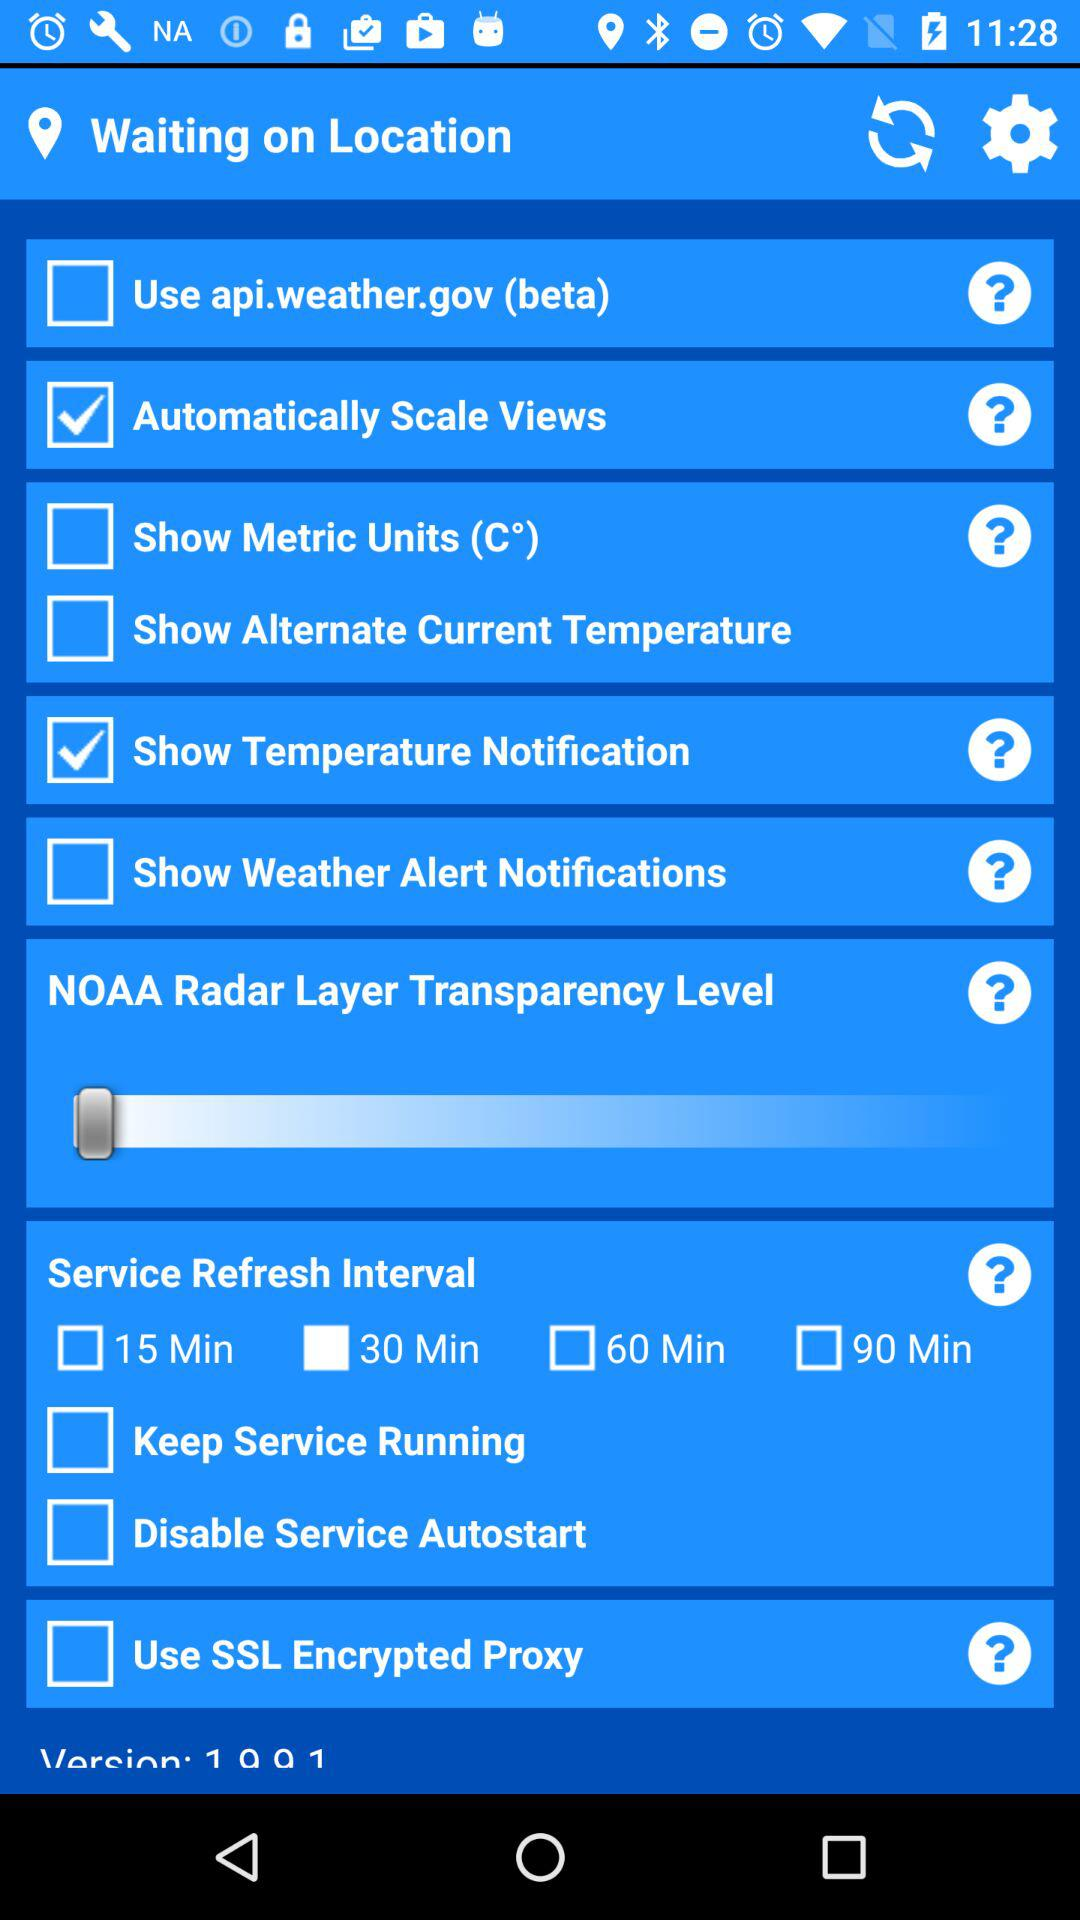How many service refresh interval options are there?
Answer the question using a single word or phrase. 4 